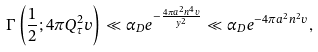<formula> <loc_0><loc_0><loc_500><loc_500>\Gamma \left ( \frac { 1 } { 2 } ; 4 \pi Q _ { \tau } ^ { 2 } v \right ) \ll \alpha _ { D } e ^ { - \frac { 4 \pi a ^ { 2 } n ^ { 4 } v } { y ^ { 2 } } } \ll \alpha _ { D } e ^ { - 4 \pi a ^ { 2 } n ^ { 2 } v } ,</formula> 